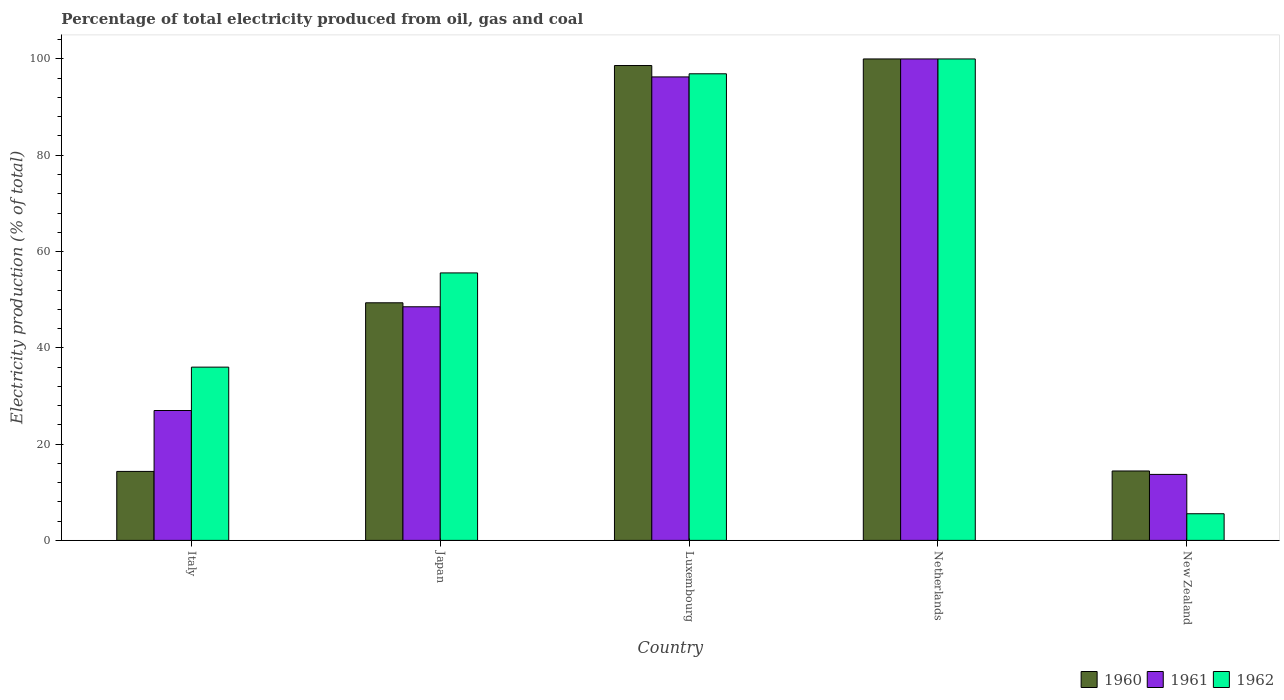How many groups of bars are there?
Give a very brief answer. 5. What is the label of the 2nd group of bars from the left?
Give a very brief answer. Japan. What is the electricity production in in 1961 in Italy?
Provide a succinct answer. 26.98. Across all countries, what is the minimum electricity production in in 1961?
Your answer should be compact. 13.71. In which country was the electricity production in in 1960 maximum?
Offer a terse response. Netherlands. In which country was the electricity production in in 1961 minimum?
Keep it short and to the point. New Zealand. What is the total electricity production in in 1960 in the graph?
Provide a short and direct response. 276.73. What is the difference between the electricity production in in 1962 in Luxembourg and that in Netherlands?
Provide a succinct answer. -3.08. What is the difference between the electricity production in in 1961 in Japan and the electricity production in in 1962 in New Zealand?
Your response must be concise. 42.99. What is the average electricity production in in 1962 per country?
Provide a succinct answer. 58.8. What is the difference between the electricity production in of/in 1962 and electricity production in of/in 1960 in Luxembourg?
Your answer should be very brief. -1.72. What is the ratio of the electricity production in in 1961 in Netherlands to that in New Zealand?
Your answer should be compact. 7.29. What is the difference between the highest and the second highest electricity production in in 1962?
Ensure brevity in your answer.  -3.08. What is the difference between the highest and the lowest electricity production in in 1962?
Your response must be concise. 94.46. Is the sum of the electricity production in in 1961 in Japan and Netherlands greater than the maximum electricity production in in 1960 across all countries?
Your response must be concise. Yes. What does the 3rd bar from the right in Japan represents?
Provide a succinct answer. 1960. Is it the case that in every country, the sum of the electricity production in in 1961 and electricity production in in 1960 is greater than the electricity production in in 1962?
Your answer should be compact. Yes. How many bars are there?
Provide a short and direct response. 15. Are all the bars in the graph horizontal?
Make the answer very short. No. How many countries are there in the graph?
Provide a short and direct response. 5. What is the difference between two consecutive major ticks on the Y-axis?
Offer a terse response. 20. Does the graph contain grids?
Make the answer very short. No. How many legend labels are there?
Provide a succinct answer. 3. How are the legend labels stacked?
Your answer should be very brief. Horizontal. What is the title of the graph?
Keep it short and to the point. Percentage of total electricity produced from oil, gas and coal. Does "1984" appear as one of the legend labels in the graph?
Give a very brief answer. No. What is the label or title of the X-axis?
Offer a terse response. Country. What is the label or title of the Y-axis?
Provide a succinct answer. Electricity production (% of total). What is the Electricity production (% of total) in 1960 in Italy?
Ensure brevity in your answer.  14.33. What is the Electricity production (% of total) of 1961 in Italy?
Your answer should be compact. 26.98. What is the Electricity production (% of total) in 1962 in Italy?
Keep it short and to the point. 35.99. What is the Electricity production (% of total) in 1960 in Japan?
Offer a very short reply. 49.35. What is the Electricity production (% of total) in 1961 in Japan?
Your response must be concise. 48.52. What is the Electricity production (% of total) in 1962 in Japan?
Provide a short and direct response. 55.56. What is the Electricity production (% of total) in 1960 in Luxembourg?
Make the answer very short. 98.63. What is the Electricity production (% of total) of 1961 in Luxembourg?
Your answer should be very brief. 96.27. What is the Electricity production (% of total) of 1962 in Luxembourg?
Make the answer very short. 96.92. What is the Electricity production (% of total) in 1960 in Netherlands?
Ensure brevity in your answer.  100. What is the Electricity production (% of total) in 1960 in New Zealand?
Provide a succinct answer. 14.42. What is the Electricity production (% of total) of 1961 in New Zealand?
Your answer should be compact. 13.71. What is the Electricity production (% of total) of 1962 in New Zealand?
Offer a terse response. 5.54. Across all countries, what is the maximum Electricity production (% of total) in 1961?
Offer a terse response. 100. Across all countries, what is the maximum Electricity production (% of total) of 1962?
Your response must be concise. 100. Across all countries, what is the minimum Electricity production (% of total) in 1960?
Make the answer very short. 14.33. Across all countries, what is the minimum Electricity production (% of total) of 1961?
Provide a succinct answer. 13.71. Across all countries, what is the minimum Electricity production (% of total) in 1962?
Provide a succinct answer. 5.54. What is the total Electricity production (% of total) of 1960 in the graph?
Give a very brief answer. 276.73. What is the total Electricity production (% of total) in 1961 in the graph?
Your response must be concise. 285.48. What is the total Electricity production (% of total) of 1962 in the graph?
Your answer should be compact. 294. What is the difference between the Electricity production (% of total) in 1960 in Italy and that in Japan?
Your response must be concise. -35.02. What is the difference between the Electricity production (% of total) of 1961 in Italy and that in Japan?
Make the answer very short. -21.55. What is the difference between the Electricity production (% of total) in 1962 in Italy and that in Japan?
Ensure brevity in your answer.  -19.57. What is the difference between the Electricity production (% of total) in 1960 in Italy and that in Luxembourg?
Make the answer very short. -84.31. What is the difference between the Electricity production (% of total) in 1961 in Italy and that in Luxembourg?
Your answer should be compact. -69.29. What is the difference between the Electricity production (% of total) of 1962 in Italy and that in Luxembourg?
Provide a short and direct response. -60.93. What is the difference between the Electricity production (% of total) of 1960 in Italy and that in Netherlands?
Give a very brief answer. -85.67. What is the difference between the Electricity production (% of total) of 1961 in Italy and that in Netherlands?
Make the answer very short. -73.02. What is the difference between the Electricity production (% of total) in 1962 in Italy and that in Netherlands?
Your answer should be very brief. -64.01. What is the difference between the Electricity production (% of total) in 1960 in Italy and that in New Zealand?
Ensure brevity in your answer.  -0.09. What is the difference between the Electricity production (% of total) in 1961 in Italy and that in New Zealand?
Offer a terse response. 13.27. What is the difference between the Electricity production (% of total) of 1962 in Italy and that in New Zealand?
Provide a succinct answer. 30.45. What is the difference between the Electricity production (% of total) in 1960 in Japan and that in Luxembourg?
Ensure brevity in your answer.  -49.28. What is the difference between the Electricity production (% of total) of 1961 in Japan and that in Luxembourg?
Your response must be concise. -47.75. What is the difference between the Electricity production (% of total) of 1962 in Japan and that in Luxembourg?
Give a very brief answer. -41.36. What is the difference between the Electricity production (% of total) of 1960 in Japan and that in Netherlands?
Offer a very short reply. -50.65. What is the difference between the Electricity production (% of total) of 1961 in Japan and that in Netherlands?
Provide a short and direct response. -51.48. What is the difference between the Electricity production (% of total) of 1962 in Japan and that in Netherlands?
Offer a terse response. -44.44. What is the difference between the Electricity production (% of total) in 1960 in Japan and that in New Zealand?
Your answer should be very brief. 34.93. What is the difference between the Electricity production (% of total) in 1961 in Japan and that in New Zealand?
Ensure brevity in your answer.  34.82. What is the difference between the Electricity production (% of total) of 1962 in Japan and that in New Zealand?
Keep it short and to the point. 50.02. What is the difference between the Electricity production (% of total) of 1960 in Luxembourg and that in Netherlands?
Offer a terse response. -1.37. What is the difference between the Electricity production (% of total) of 1961 in Luxembourg and that in Netherlands?
Provide a short and direct response. -3.73. What is the difference between the Electricity production (% of total) in 1962 in Luxembourg and that in Netherlands?
Provide a short and direct response. -3.08. What is the difference between the Electricity production (% of total) of 1960 in Luxembourg and that in New Zealand?
Provide a short and direct response. 84.22. What is the difference between the Electricity production (% of total) of 1961 in Luxembourg and that in New Zealand?
Provide a succinct answer. 82.56. What is the difference between the Electricity production (% of total) in 1962 in Luxembourg and that in New Zealand?
Provide a succinct answer. 91.38. What is the difference between the Electricity production (% of total) of 1960 in Netherlands and that in New Zealand?
Ensure brevity in your answer.  85.58. What is the difference between the Electricity production (% of total) in 1961 in Netherlands and that in New Zealand?
Offer a terse response. 86.29. What is the difference between the Electricity production (% of total) of 1962 in Netherlands and that in New Zealand?
Ensure brevity in your answer.  94.46. What is the difference between the Electricity production (% of total) in 1960 in Italy and the Electricity production (% of total) in 1961 in Japan?
Your response must be concise. -34.2. What is the difference between the Electricity production (% of total) of 1960 in Italy and the Electricity production (% of total) of 1962 in Japan?
Offer a very short reply. -41.23. What is the difference between the Electricity production (% of total) in 1961 in Italy and the Electricity production (% of total) in 1962 in Japan?
Provide a succinct answer. -28.58. What is the difference between the Electricity production (% of total) in 1960 in Italy and the Electricity production (% of total) in 1961 in Luxembourg?
Provide a short and direct response. -81.94. What is the difference between the Electricity production (% of total) of 1960 in Italy and the Electricity production (% of total) of 1962 in Luxembourg?
Your response must be concise. -82.59. What is the difference between the Electricity production (% of total) in 1961 in Italy and the Electricity production (% of total) in 1962 in Luxembourg?
Ensure brevity in your answer.  -69.94. What is the difference between the Electricity production (% of total) in 1960 in Italy and the Electricity production (% of total) in 1961 in Netherlands?
Your response must be concise. -85.67. What is the difference between the Electricity production (% of total) of 1960 in Italy and the Electricity production (% of total) of 1962 in Netherlands?
Offer a very short reply. -85.67. What is the difference between the Electricity production (% of total) in 1961 in Italy and the Electricity production (% of total) in 1962 in Netherlands?
Your response must be concise. -73.02. What is the difference between the Electricity production (% of total) in 1960 in Italy and the Electricity production (% of total) in 1961 in New Zealand?
Provide a succinct answer. 0.62. What is the difference between the Electricity production (% of total) in 1960 in Italy and the Electricity production (% of total) in 1962 in New Zealand?
Offer a terse response. 8.79. What is the difference between the Electricity production (% of total) in 1961 in Italy and the Electricity production (% of total) in 1962 in New Zealand?
Offer a very short reply. 21.44. What is the difference between the Electricity production (% of total) in 1960 in Japan and the Electricity production (% of total) in 1961 in Luxembourg?
Your response must be concise. -46.92. What is the difference between the Electricity production (% of total) in 1960 in Japan and the Electricity production (% of total) in 1962 in Luxembourg?
Make the answer very short. -47.57. What is the difference between the Electricity production (% of total) in 1961 in Japan and the Electricity production (% of total) in 1962 in Luxembourg?
Your response must be concise. -48.39. What is the difference between the Electricity production (% of total) in 1960 in Japan and the Electricity production (% of total) in 1961 in Netherlands?
Offer a terse response. -50.65. What is the difference between the Electricity production (% of total) of 1960 in Japan and the Electricity production (% of total) of 1962 in Netherlands?
Give a very brief answer. -50.65. What is the difference between the Electricity production (% of total) of 1961 in Japan and the Electricity production (% of total) of 1962 in Netherlands?
Make the answer very short. -51.48. What is the difference between the Electricity production (% of total) of 1960 in Japan and the Electricity production (% of total) of 1961 in New Zealand?
Your answer should be compact. 35.64. What is the difference between the Electricity production (% of total) in 1960 in Japan and the Electricity production (% of total) in 1962 in New Zealand?
Your response must be concise. 43.81. What is the difference between the Electricity production (% of total) in 1961 in Japan and the Electricity production (% of total) in 1962 in New Zealand?
Give a very brief answer. 42.99. What is the difference between the Electricity production (% of total) in 1960 in Luxembourg and the Electricity production (% of total) in 1961 in Netherlands?
Offer a terse response. -1.37. What is the difference between the Electricity production (% of total) of 1960 in Luxembourg and the Electricity production (% of total) of 1962 in Netherlands?
Keep it short and to the point. -1.37. What is the difference between the Electricity production (% of total) in 1961 in Luxembourg and the Electricity production (% of total) in 1962 in Netherlands?
Offer a very short reply. -3.73. What is the difference between the Electricity production (% of total) in 1960 in Luxembourg and the Electricity production (% of total) in 1961 in New Zealand?
Give a very brief answer. 84.93. What is the difference between the Electricity production (% of total) in 1960 in Luxembourg and the Electricity production (% of total) in 1962 in New Zealand?
Ensure brevity in your answer.  93.1. What is the difference between the Electricity production (% of total) of 1961 in Luxembourg and the Electricity production (% of total) of 1962 in New Zealand?
Ensure brevity in your answer.  90.73. What is the difference between the Electricity production (% of total) in 1960 in Netherlands and the Electricity production (% of total) in 1961 in New Zealand?
Provide a succinct answer. 86.29. What is the difference between the Electricity production (% of total) in 1960 in Netherlands and the Electricity production (% of total) in 1962 in New Zealand?
Your answer should be very brief. 94.46. What is the difference between the Electricity production (% of total) of 1961 in Netherlands and the Electricity production (% of total) of 1962 in New Zealand?
Make the answer very short. 94.46. What is the average Electricity production (% of total) in 1960 per country?
Give a very brief answer. 55.35. What is the average Electricity production (% of total) of 1961 per country?
Your answer should be very brief. 57.1. What is the average Electricity production (% of total) of 1962 per country?
Provide a succinct answer. 58.8. What is the difference between the Electricity production (% of total) of 1960 and Electricity production (% of total) of 1961 in Italy?
Give a very brief answer. -12.65. What is the difference between the Electricity production (% of total) in 1960 and Electricity production (% of total) in 1962 in Italy?
Your answer should be very brief. -21.66. What is the difference between the Electricity production (% of total) of 1961 and Electricity production (% of total) of 1962 in Italy?
Offer a very short reply. -9.01. What is the difference between the Electricity production (% of total) of 1960 and Electricity production (% of total) of 1961 in Japan?
Ensure brevity in your answer.  0.83. What is the difference between the Electricity production (% of total) of 1960 and Electricity production (% of total) of 1962 in Japan?
Your response must be concise. -6.2. What is the difference between the Electricity production (% of total) of 1961 and Electricity production (% of total) of 1962 in Japan?
Provide a succinct answer. -7.03. What is the difference between the Electricity production (% of total) of 1960 and Electricity production (% of total) of 1961 in Luxembourg?
Offer a very short reply. 2.36. What is the difference between the Electricity production (% of total) in 1960 and Electricity production (% of total) in 1962 in Luxembourg?
Make the answer very short. 1.72. What is the difference between the Electricity production (% of total) of 1961 and Electricity production (% of total) of 1962 in Luxembourg?
Your answer should be compact. -0.65. What is the difference between the Electricity production (% of total) in 1960 and Electricity production (% of total) in 1961 in Netherlands?
Make the answer very short. 0. What is the difference between the Electricity production (% of total) in 1960 and Electricity production (% of total) in 1962 in Netherlands?
Make the answer very short. 0. What is the difference between the Electricity production (% of total) of 1961 and Electricity production (% of total) of 1962 in Netherlands?
Your response must be concise. 0. What is the difference between the Electricity production (% of total) of 1960 and Electricity production (% of total) of 1961 in New Zealand?
Give a very brief answer. 0.71. What is the difference between the Electricity production (% of total) of 1960 and Electricity production (% of total) of 1962 in New Zealand?
Offer a terse response. 8.88. What is the difference between the Electricity production (% of total) of 1961 and Electricity production (% of total) of 1962 in New Zealand?
Provide a short and direct response. 8.17. What is the ratio of the Electricity production (% of total) of 1960 in Italy to that in Japan?
Provide a succinct answer. 0.29. What is the ratio of the Electricity production (% of total) in 1961 in Italy to that in Japan?
Keep it short and to the point. 0.56. What is the ratio of the Electricity production (% of total) in 1962 in Italy to that in Japan?
Give a very brief answer. 0.65. What is the ratio of the Electricity production (% of total) in 1960 in Italy to that in Luxembourg?
Offer a very short reply. 0.15. What is the ratio of the Electricity production (% of total) of 1961 in Italy to that in Luxembourg?
Your answer should be very brief. 0.28. What is the ratio of the Electricity production (% of total) in 1962 in Italy to that in Luxembourg?
Your response must be concise. 0.37. What is the ratio of the Electricity production (% of total) in 1960 in Italy to that in Netherlands?
Provide a short and direct response. 0.14. What is the ratio of the Electricity production (% of total) of 1961 in Italy to that in Netherlands?
Offer a very short reply. 0.27. What is the ratio of the Electricity production (% of total) in 1962 in Italy to that in Netherlands?
Provide a succinct answer. 0.36. What is the ratio of the Electricity production (% of total) of 1961 in Italy to that in New Zealand?
Keep it short and to the point. 1.97. What is the ratio of the Electricity production (% of total) of 1962 in Italy to that in New Zealand?
Give a very brief answer. 6.5. What is the ratio of the Electricity production (% of total) of 1960 in Japan to that in Luxembourg?
Ensure brevity in your answer.  0.5. What is the ratio of the Electricity production (% of total) in 1961 in Japan to that in Luxembourg?
Offer a very short reply. 0.5. What is the ratio of the Electricity production (% of total) of 1962 in Japan to that in Luxembourg?
Offer a terse response. 0.57. What is the ratio of the Electricity production (% of total) of 1960 in Japan to that in Netherlands?
Offer a very short reply. 0.49. What is the ratio of the Electricity production (% of total) in 1961 in Japan to that in Netherlands?
Offer a terse response. 0.49. What is the ratio of the Electricity production (% of total) in 1962 in Japan to that in Netherlands?
Provide a short and direct response. 0.56. What is the ratio of the Electricity production (% of total) of 1960 in Japan to that in New Zealand?
Your answer should be very brief. 3.42. What is the ratio of the Electricity production (% of total) of 1961 in Japan to that in New Zealand?
Your response must be concise. 3.54. What is the ratio of the Electricity production (% of total) in 1962 in Japan to that in New Zealand?
Your response must be concise. 10.03. What is the ratio of the Electricity production (% of total) in 1960 in Luxembourg to that in Netherlands?
Ensure brevity in your answer.  0.99. What is the ratio of the Electricity production (% of total) of 1961 in Luxembourg to that in Netherlands?
Make the answer very short. 0.96. What is the ratio of the Electricity production (% of total) of 1962 in Luxembourg to that in Netherlands?
Keep it short and to the point. 0.97. What is the ratio of the Electricity production (% of total) of 1960 in Luxembourg to that in New Zealand?
Your answer should be compact. 6.84. What is the ratio of the Electricity production (% of total) of 1961 in Luxembourg to that in New Zealand?
Provide a short and direct response. 7.02. What is the ratio of the Electricity production (% of total) in 1962 in Luxembourg to that in New Zealand?
Offer a terse response. 17.51. What is the ratio of the Electricity production (% of total) of 1960 in Netherlands to that in New Zealand?
Provide a short and direct response. 6.94. What is the ratio of the Electricity production (% of total) in 1961 in Netherlands to that in New Zealand?
Provide a succinct answer. 7.29. What is the ratio of the Electricity production (% of total) in 1962 in Netherlands to that in New Zealand?
Give a very brief answer. 18.06. What is the difference between the highest and the second highest Electricity production (% of total) of 1960?
Your response must be concise. 1.37. What is the difference between the highest and the second highest Electricity production (% of total) of 1961?
Keep it short and to the point. 3.73. What is the difference between the highest and the second highest Electricity production (% of total) of 1962?
Make the answer very short. 3.08. What is the difference between the highest and the lowest Electricity production (% of total) of 1960?
Your answer should be compact. 85.67. What is the difference between the highest and the lowest Electricity production (% of total) in 1961?
Offer a very short reply. 86.29. What is the difference between the highest and the lowest Electricity production (% of total) in 1962?
Make the answer very short. 94.46. 